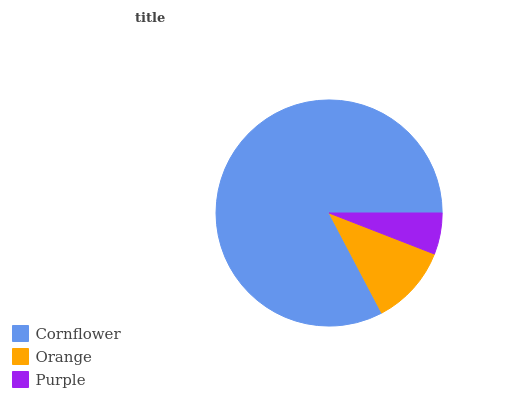Is Purple the minimum?
Answer yes or no. Yes. Is Cornflower the maximum?
Answer yes or no. Yes. Is Orange the minimum?
Answer yes or no. No. Is Orange the maximum?
Answer yes or no. No. Is Cornflower greater than Orange?
Answer yes or no. Yes. Is Orange less than Cornflower?
Answer yes or no. Yes. Is Orange greater than Cornflower?
Answer yes or no. No. Is Cornflower less than Orange?
Answer yes or no. No. Is Orange the high median?
Answer yes or no. Yes. Is Orange the low median?
Answer yes or no. Yes. Is Purple the high median?
Answer yes or no. No. Is Cornflower the low median?
Answer yes or no. No. 